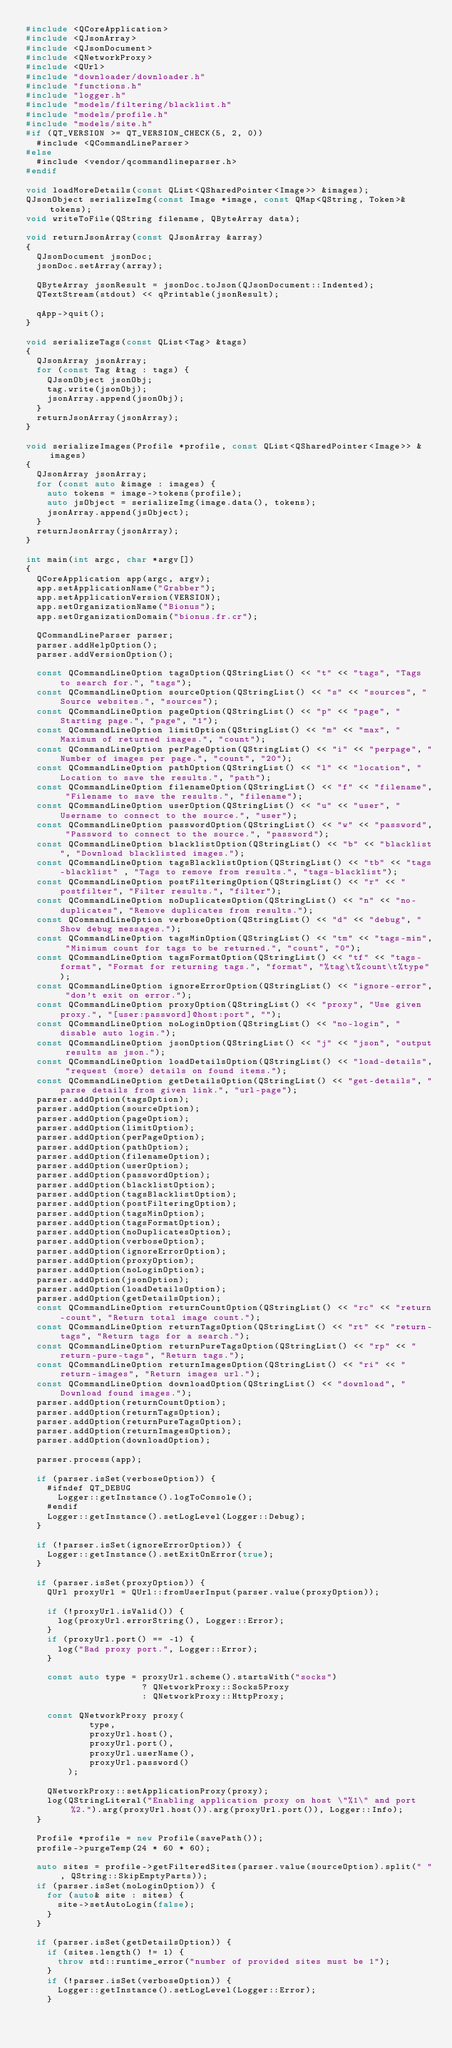<code> <loc_0><loc_0><loc_500><loc_500><_C++_>#include <QCoreApplication>
#include <QJsonArray>
#include <QJsonDocument>
#include <QNetworkProxy>
#include <QUrl>
#include "downloader/downloader.h"
#include "functions.h"
#include "logger.h"
#include "models/filtering/blacklist.h"
#include "models/profile.h"
#include "models/site.h"
#if (QT_VERSION >= QT_VERSION_CHECK(5, 2, 0))
	#include <QCommandLineParser>
#else
	#include <vendor/qcommandlineparser.h>
#endif

void loadMoreDetails(const QList<QSharedPointer<Image>> &images);
QJsonObject serializeImg(const Image *image, const QMap<QString, Token>& tokens);
void writeToFile(QString filename, QByteArray data);

void returnJsonArray(const QJsonArray &array)
{
	QJsonDocument jsonDoc;
	jsonDoc.setArray(array);

	QByteArray jsonResult = jsonDoc.toJson(QJsonDocument::Indented);
	QTextStream(stdout) << qPrintable(jsonResult);

	qApp->quit();
}

void serializeTags(const QList<Tag> &tags)
{
	QJsonArray jsonArray;
	for (const Tag &tag : tags) {
		QJsonObject jsonObj;
		tag.write(jsonObj);
		jsonArray.append(jsonObj);
	}
	returnJsonArray(jsonArray);
}

void serializeImages(Profile *profile, const QList<QSharedPointer<Image>> &images)
{
	QJsonArray jsonArray;
	for (const auto &image : images) {
		auto tokens = image->tokens(profile);
		auto jsObject = serializeImg(image.data(), tokens);
		jsonArray.append(jsObject);
	}
	returnJsonArray(jsonArray);
}

int main(int argc, char *argv[])
{
	QCoreApplication app(argc, argv);
	app.setApplicationName("Grabber");
	app.setApplicationVersion(VERSION);
	app.setOrganizationName("Bionus");
	app.setOrganizationDomain("bionus.fr.cr");

	QCommandLineParser parser;
	parser.addHelpOption();
	parser.addVersionOption();

	const QCommandLineOption tagsOption(QStringList() << "t" << "tags", "Tags to search for.", "tags");
	const QCommandLineOption sourceOption(QStringList() << "s" << "sources", "Source websites.", "sources");
	const QCommandLineOption pageOption(QStringList() << "p" << "page", "Starting page.", "page", "1");
	const QCommandLineOption limitOption(QStringList() << "m" << "max", "Maximum of returned images.", "count");
	const QCommandLineOption perPageOption(QStringList() << "i" << "perpage", "Number of images per page.", "count", "20");
	const QCommandLineOption pathOption(QStringList() << "l" << "location", "Location to save the results.", "path");
	const QCommandLineOption filenameOption(QStringList() << "f" << "filename", "Filename to save the results.", "filename");
	const QCommandLineOption userOption(QStringList() << "u" << "user", "Username to connect to the source.", "user");
	const QCommandLineOption passwordOption(QStringList() << "w" << "password", "Password to connect to the source.", "password");
	const QCommandLineOption blacklistOption(QStringList() << "b" << "blacklist", "Download blacklisted images.");
	const QCommandLineOption tagsBlacklistOption(QStringList() << "tb" << "tags-blacklist" , "Tags to remove from results.", "tags-blacklist");
	const QCommandLineOption postFilteringOption(QStringList() << "r" << "postfilter", "Filter results.", "filter");
	const QCommandLineOption noDuplicatesOption(QStringList() << "n" << "no-duplicates", "Remove duplicates from results.");
	const QCommandLineOption verboseOption(QStringList() << "d" << "debug", "Show debug messages.");
	const QCommandLineOption tagsMinOption(QStringList() << "tm" << "tags-min", "Minimum count for tags to be returned.", "count", "0");
	const QCommandLineOption tagsFormatOption(QStringList() << "tf" << "tags-format", "Format for returning tags.", "format", "%tag\t%count\t%type");
	const QCommandLineOption ignoreErrorOption(QStringList() << "ignore-error", "don't exit on error.");
	const QCommandLineOption proxyOption(QStringList() << "proxy", "Use given proxy.", "[user:password]@host:port", "");
	const QCommandLineOption noLoginOption(QStringList() << "no-login", "disable auto login.");
	const QCommandLineOption jsonOption(QStringList() << "j" << "json", "output results as json.");
	const QCommandLineOption loadDetailsOption(QStringList() << "load-details", "request (more) details on found items.");
	const QCommandLineOption getDetailsOption(QStringList() << "get-details", "parse details from given link.", "url-page");
	parser.addOption(tagsOption);
	parser.addOption(sourceOption);
	parser.addOption(pageOption);
	parser.addOption(limitOption);
	parser.addOption(perPageOption);
	parser.addOption(pathOption);
	parser.addOption(filenameOption);
	parser.addOption(userOption);
	parser.addOption(passwordOption);
	parser.addOption(blacklistOption);
	parser.addOption(tagsBlacklistOption);
	parser.addOption(postFilteringOption);
	parser.addOption(tagsMinOption);
	parser.addOption(tagsFormatOption);
	parser.addOption(noDuplicatesOption);
	parser.addOption(verboseOption);
	parser.addOption(ignoreErrorOption);
	parser.addOption(proxyOption);
	parser.addOption(noLoginOption);
	parser.addOption(jsonOption);
	parser.addOption(loadDetailsOption);
	parser.addOption(getDetailsOption);
	const QCommandLineOption returnCountOption(QStringList() << "rc" << "return-count", "Return total image count.");
	const QCommandLineOption returnTagsOption(QStringList() << "rt" << "return-tags", "Return tags for a search.");
	const QCommandLineOption returnPureTagsOption(QStringList() << "rp" << "return-pure-tags", "Return tags.");
	const QCommandLineOption returnImagesOption(QStringList() << "ri" << "return-images", "Return images url.");
	const QCommandLineOption downloadOption(QStringList() << "download", "Download found images.");
	parser.addOption(returnCountOption);
	parser.addOption(returnTagsOption);
	parser.addOption(returnPureTagsOption);
	parser.addOption(returnImagesOption);
	parser.addOption(downloadOption);

	parser.process(app);

	if (parser.isSet(verboseOption)) {
		#ifndef QT_DEBUG
			Logger::getInstance().logToConsole();
		#endif
		Logger::getInstance().setLogLevel(Logger::Debug);
	}

	if (!parser.isSet(ignoreErrorOption)) {
		Logger::getInstance().setExitOnError(true);
	}

	if (parser.isSet(proxyOption)) {
		QUrl proxyUrl = QUrl::fromUserInput(parser.value(proxyOption));

		if (!proxyUrl.isValid()) {
			log(proxyUrl.errorString(), Logger::Error);
		}
		if (proxyUrl.port() == -1) {
			log("Bad proxy port.", Logger::Error);
		}

		const auto type = proxyUrl.scheme().startsWith("socks")
		                  ? QNetworkProxy::Socks5Proxy
		                  : QNetworkProxy::HttpProxy;

		const QNetworkProxy proxy(
		        type,
		        proxyUrl.host(),
		        proxyUrl.port(),
		        proxyUrl.userName(),
		        proxyUrl.password()
		    );

		QNetworkProxy::setApplicationProxy(proxy);
		log(QStringLiteral("Enabling application proxy on host \"%1\" and port %2.").arg(proxyUrl.host()).arg(proxyUrl.port()), Logger::Info);
	}

	Profile *profile = new Profile(savePath());
	profile->purgeTemp(24 * 60 * 60);

	auto sites = profile->getFilteredSites(parser.value(sourceOption).split(" ", QString::SkipEmptyParts));
	if (parser.isSet(noLoginOption)) {
		for (auto& site : sites) {
			site->setAutoLogin(false);
		}
	}

	if (parser.isSet(getDetailsOption)) {
		if (sites.length() != 1) {
			throw std::runtime_error("number of provided sites must be 1");
		}
		if (!parser.isSet(verboseOption)) {
			Logger::getInstance().setLogLevel(Logger::Error);
		}
</code> 